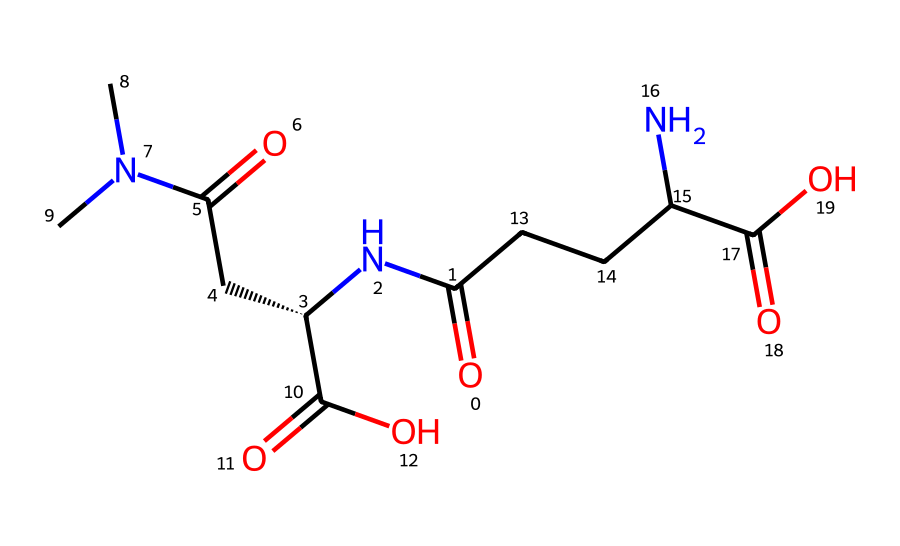How many nitrogen atoms are in the molecular structure? By examining the SMILES representation, we identify each occurrence of the letter 'N', which represents a nitrogen atom. In this structure, there are three instances of 'N.'
Answer: three What is the molecular weight of L-theanine? To determine the molecular weight, we typically need to sum the atomic weights of each atom in the structure. For L-theanine, it is approximately 174.2 g/mol when calculated based on its molecular composition.
Answer: 174.2 g/mol What functional groups are identified in L-theanine? The structure contains an amine group (–NH2) and carboxylic acid groups (–COOH), identifiable by the presence of nitrogen and carbonyl groups, respectively.
Answer: amine and carboxylic acid How many total carbon atoms are present in L-theanine? By counting the 'C' occurrences in the SMILES notation, one can determine there are eight carbon atoms in the structure of L-theanine.
Answer: eight What characteristic does L-theanine acquire due to its amino acid structure? As an amino acid, L-theanine contains both amino (–NH2) and carboxyl (–COOH) functional groups, which confer its ability to participate in protein synthesis and contribute to its relaxation properties.
Answer: amino acid Is L-theanine a polar or non-polar molecule? Analyzing the presence of functional groups (such as amino and carboxyl groups) reveals a polar nature due to the electronegative atoms in those groups, which interact with water.
Answer: polar 